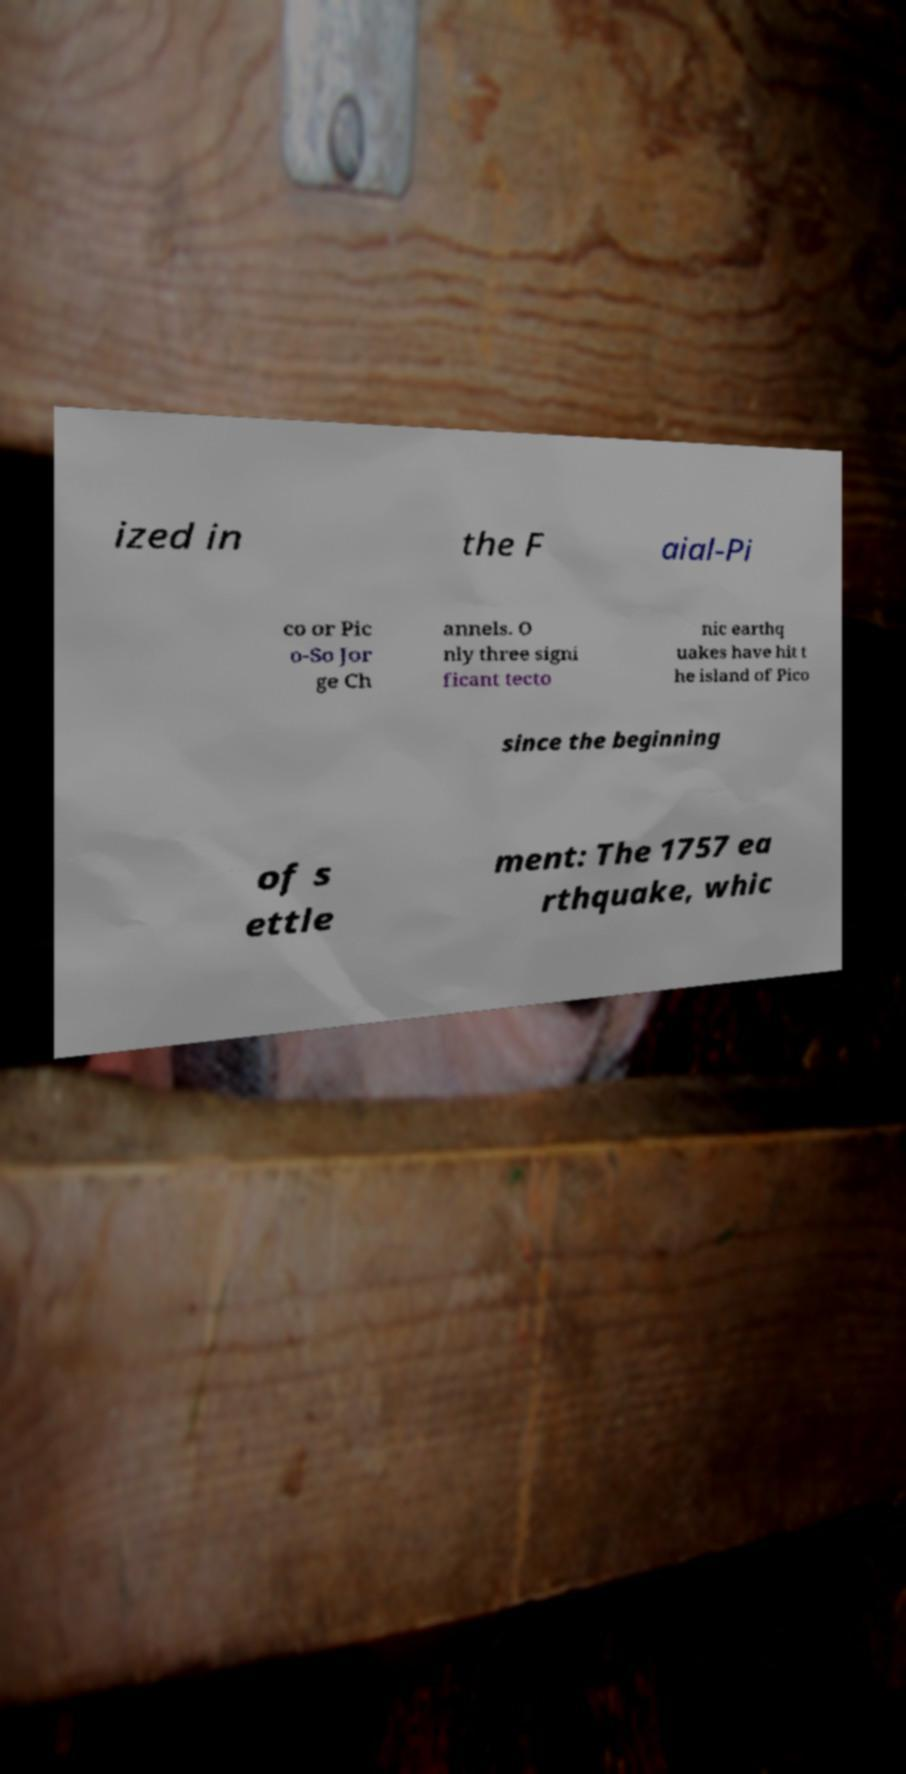Please read and relay the text visible in this image. What does it say? ized in the F aial-Pi co or Pic o-So Jor ge Ch annels. O nly three signi ficant tecto nic earthq uakes have hit t he island of Pico since the beginning of s ettle ment: The 1757 ea rthquake, whic 